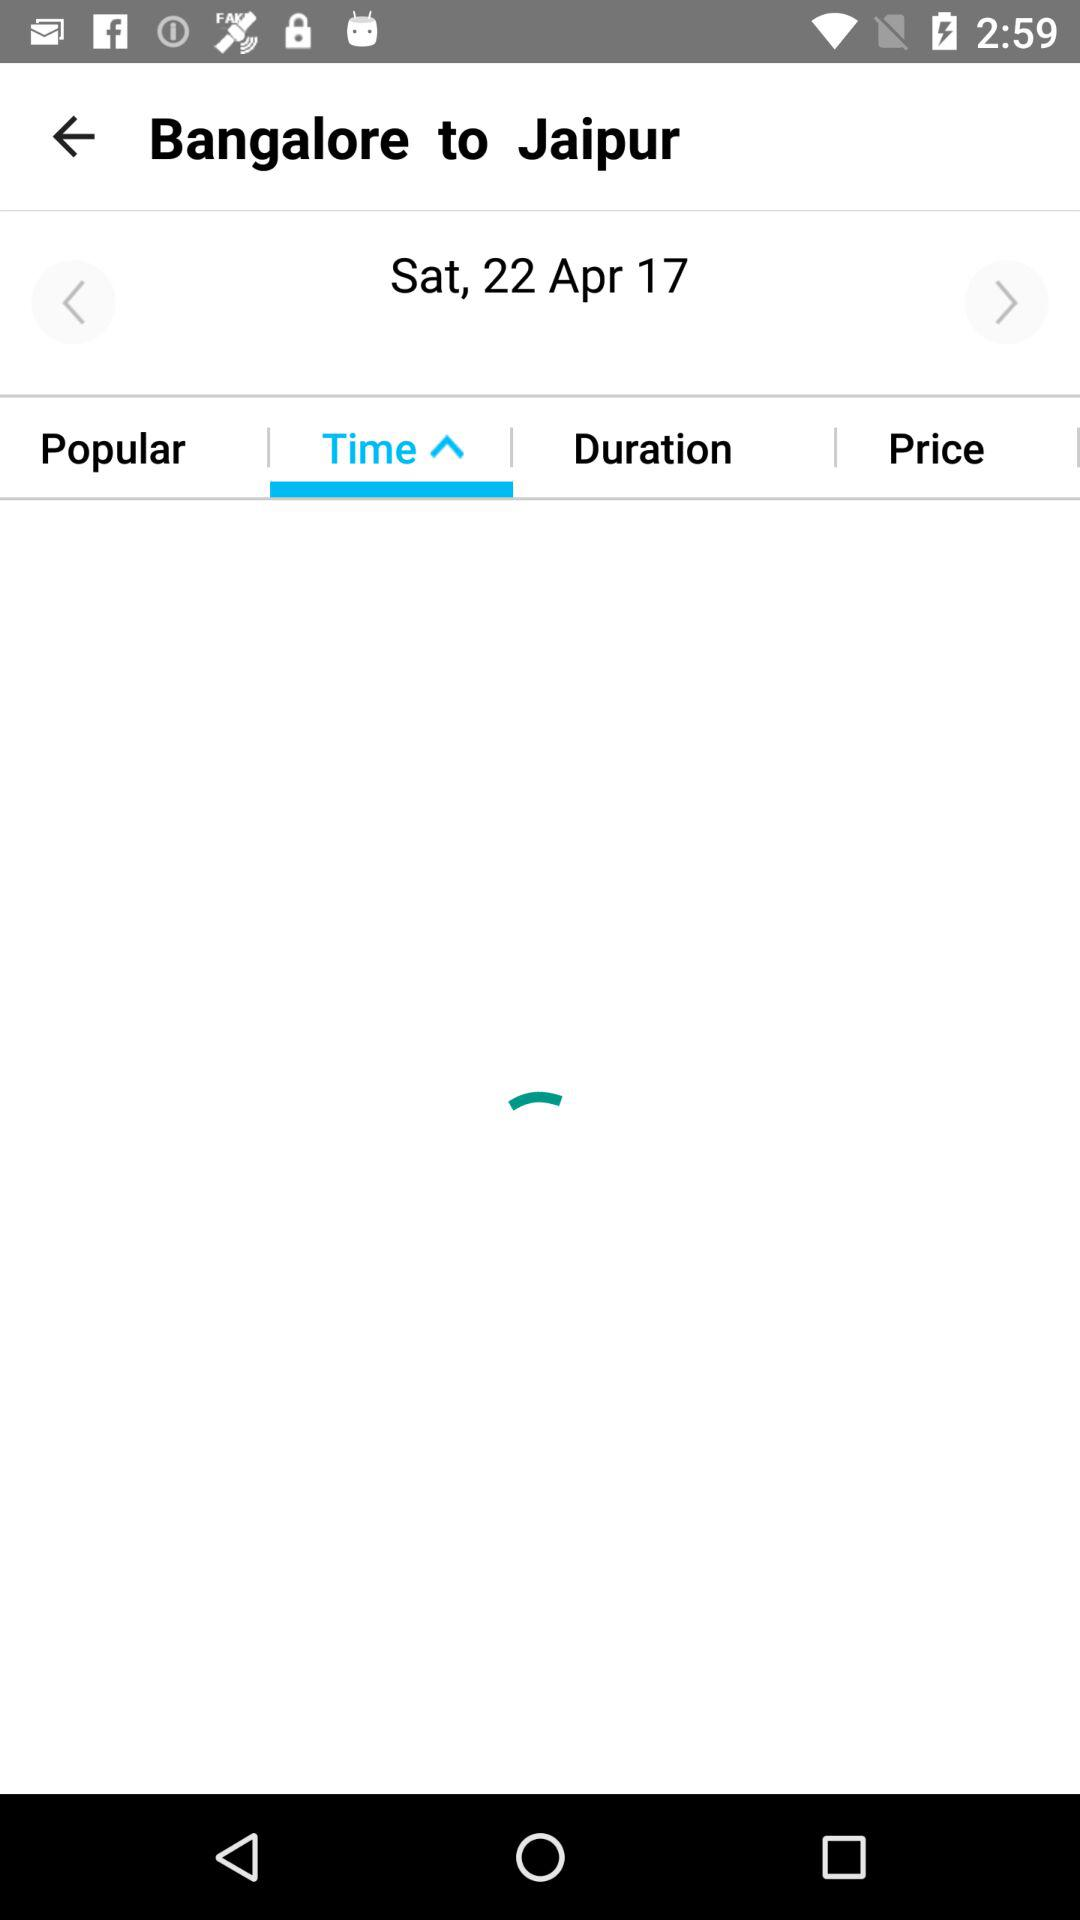From which city to which city is given for travel? The city is from Bangalore to Jaipur. 